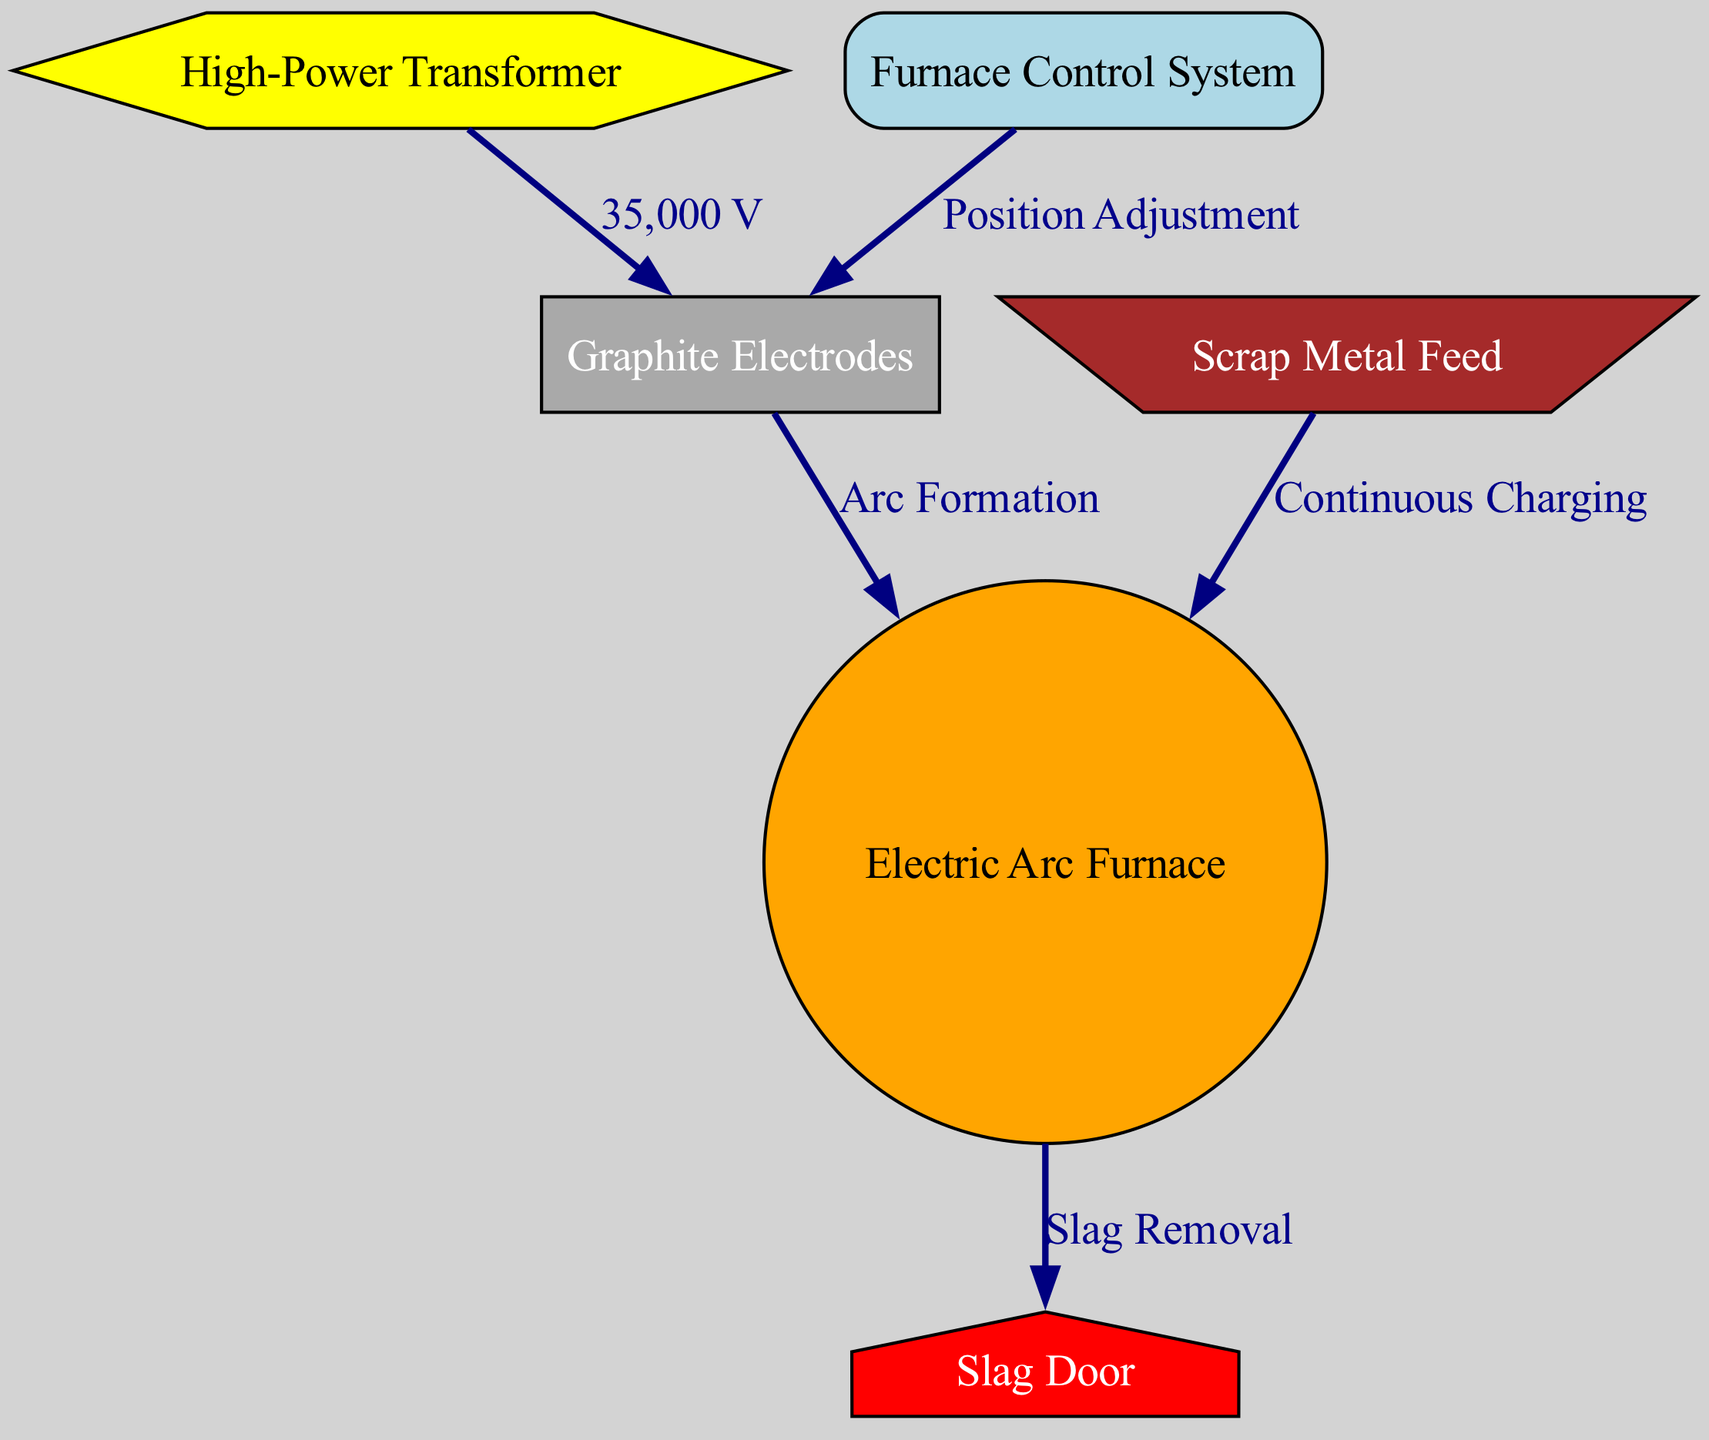What is the voltage supplied by the power supply? The power supply connects to the electrodes, and the edge label indicates that it provides 35,000 volts, as stated in the diagram.
Answer: 35,000 V What is the main input material for the electric arc furnace? The scrap feed node directly connects to the furnace node, indicating that scrap metal is continuously charged into the furnace.
Answer: Scrap Metal Feed What is the function of the control system in relation to the electrodes? The control system has an edge labeled "Position Adjustment" pointing to the electrodes, showing that it is responsible for adjusting their position.
Answer: Position Adjustment How many nodes are present in the diagram? By counting each unique node represented in the diagram, we find that there are six nodes in total: electric arc furnace, graphite electrodes, high-power transformer, furnace control system, scrap metal feed, and slag door.
Answer: Six What is the flow of operation after the scrap feed enters the furnace? Following the scrap feed, which continuously charges the furnace, the next step indicated is the removal of slag through the slag door as part of the process flow.
Answer: Slag Removal What type of node is represented by the slag door? The slag door node is shaped like a house, which is characteristic of a specific type of shape used in the diagram for that function.
Answer: House What connects the high-power transformer to the graphite electrodes? An edge labeled "35,000 V" directly connects the transformer to the electrodes, indicating the type of connection and the voltage involved.
Answer: 35,000 V What process occurs between the graphite electrodes and the electric arc furnace? The edge between the two nodes is labeled "Arc Formation," which describes the specific process occurring as the electrodes create an arc within the furnace.
Answer: Arc Formation What action is indicated by the arrow from the furnace to the slag door? The edge labeled "Slag Removal" signifies the action of removing slag that accumulates during the operation of the furnace, showing a key output of the process.
Answer: Slag Removal 